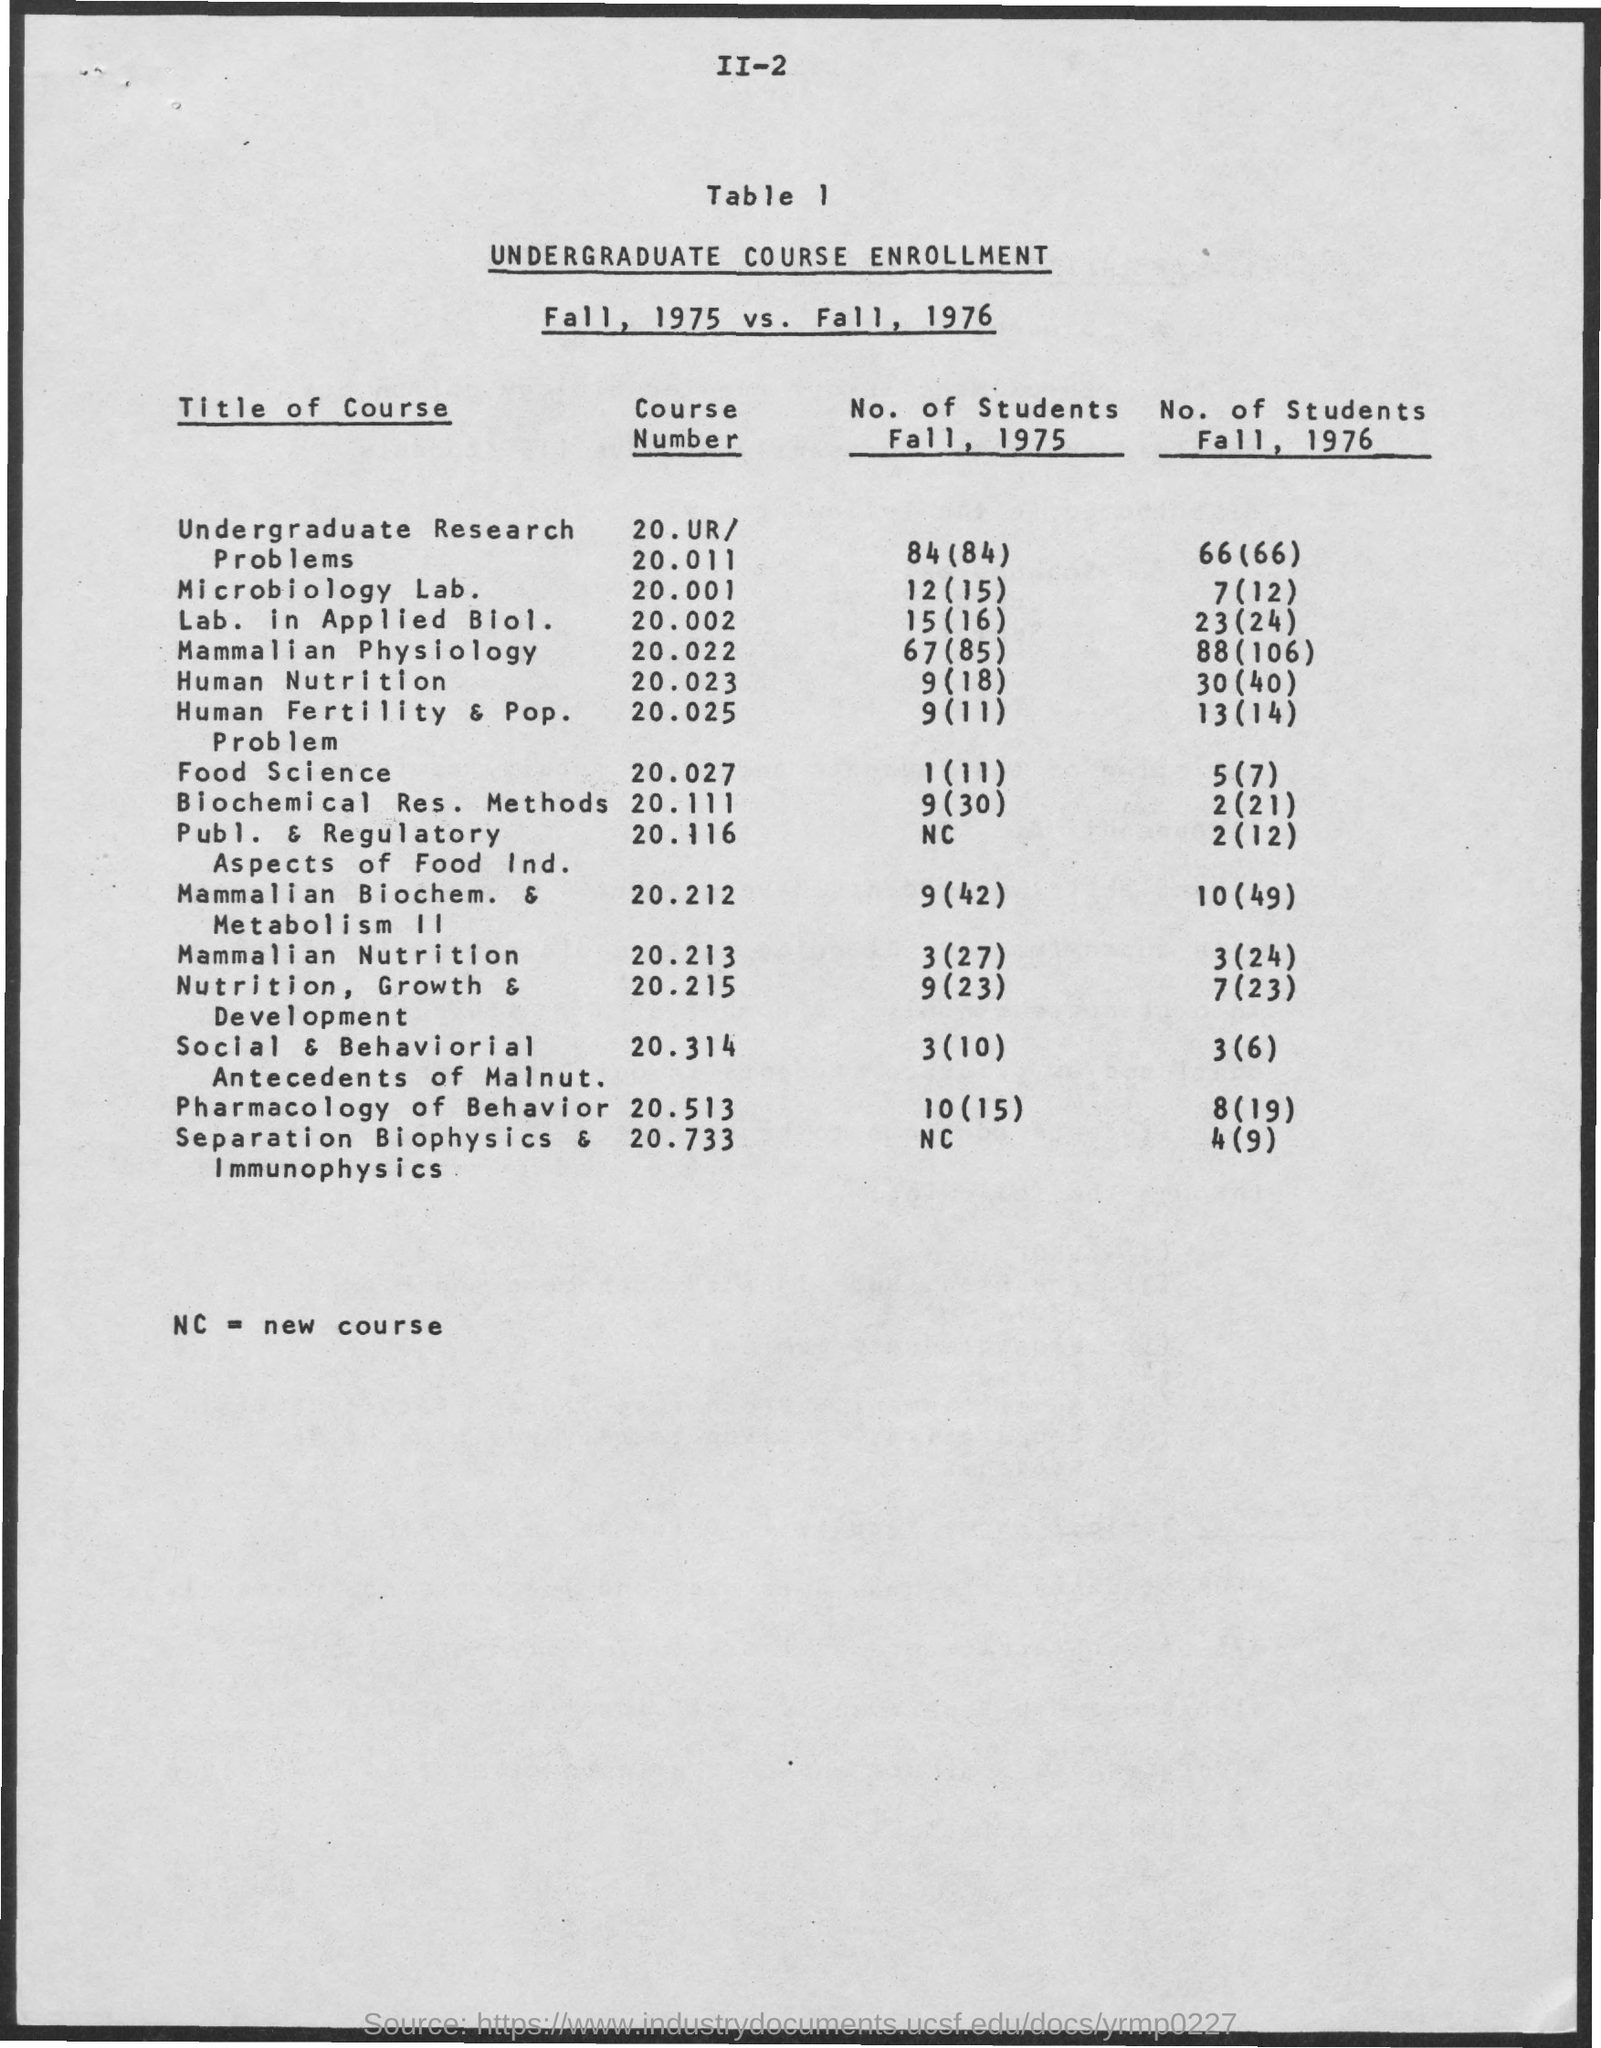Point out several critical features in this image. The number of students enrolled in course Number 20.011 during the Fall semester of 1975 was 84. In the Fall 1975 semester, there were 67 students enrolled in course number 20.022. There were 15 students in the Fall 1975 for course number 20.002. There were a total of 30 students enrolled in course number 20.116 during the fall semester of 1975. The number of students enrolled in course 20.212 during the fall semester of 1975 was 9. 